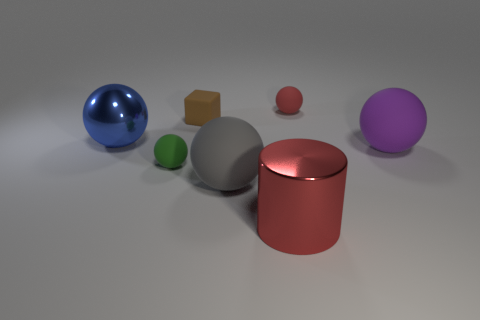Subtract all metal balls. How many balls are left? 4 Add 1 big brown metallic things. How many objects exist? 8 Subtract all purple spheres. How many spheres are left? 4 Subtract all spheres. How many objects are left? 2 Subtract all purple cubes. How many gray spheres are left? 1 Subtract all large gray rubber balls. Subtract all brown matte things. How many objects are left? 5 Add 4 tiny green balls. How many tiny green balls are left? 5 Add 7 brown blocks. How many brown blocks exist? 8 Subtract 1 gray balls. How many objects are left? 6 Subtract 4 spheres. How many spheres are left? 1 